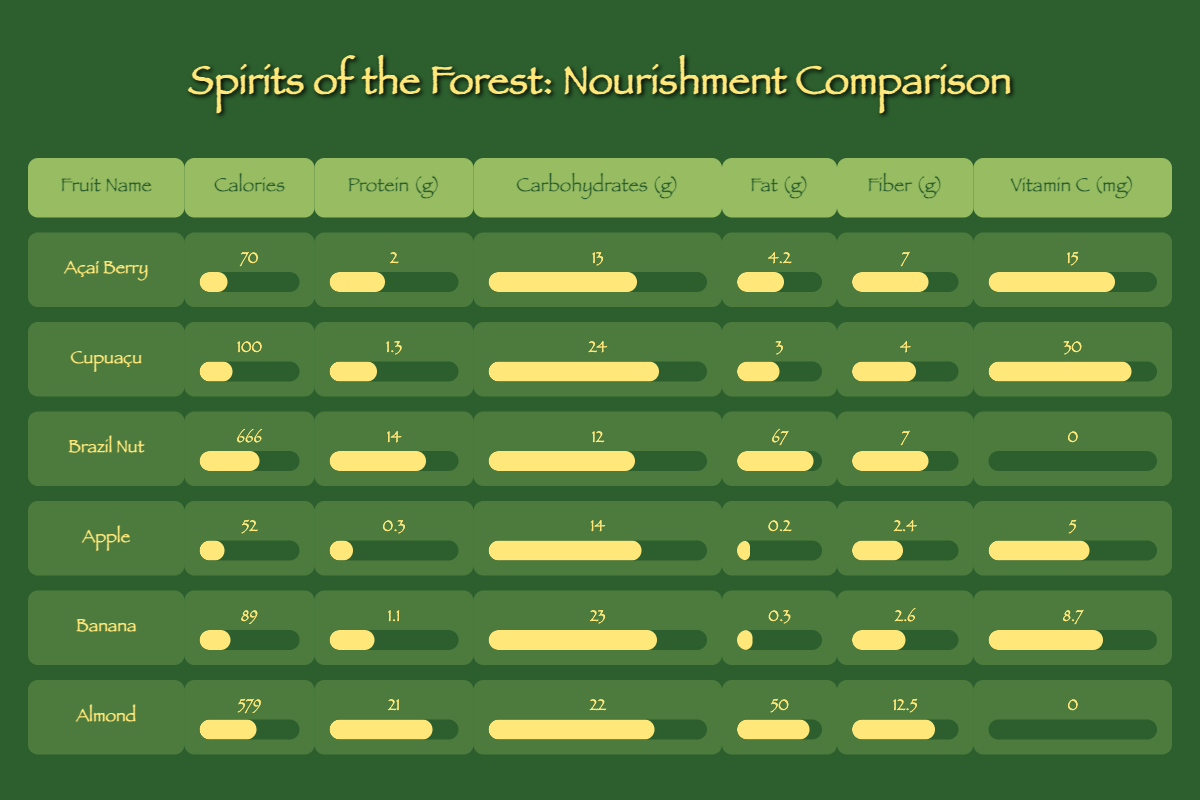What fruit has the highest calories among indigenous options? By looking at the indigenous fruits listed, the Brazil Nut has 666 calories, which is higher than Açaí Berry (70 calories) and Cupuaçu (100 calories).
Answer: Brazil Nut What is the vitamin C content of Cupuaçu? The vitamin C content of Cupuaçu is listed as 30 mg in the table.
Answer: 30 mg Which fruit has the highest fat content among cultivated fruits? The table shows that Almond has the highest fat content at 50 grams, compared to Apple (0.2 grams) and Banana (0.3 grams).
Answer: Almond Calculate the average protein content of indigenous fruits. The protein values for indigenous fruits are 2, 1.3, and 14 grams. The sum is 2 + 1.3 + 14 = 17. Dividing by 3 gives an average of 17/3 = 5.67 grams.
Answer: 5.67 grams Is it true that all cultivated fruits have higher calories than indigenous fruits? No, it's not true. The Brazil Nut has 666 calories, which is more than any cultivated fruit (Apple with 52 calories, Banana with 89 calories, Almond with 579 calories).
Answer: No What is the total carbohydrate content among indigenous fruits? The carbohydrate values for indigenous fruits are 13 (Açaí Berry) + 24 (Cupuaçu) + 12 (Brazil Nut) = 49 grams.
Answer: 49 grams Which fruit has the least fiber content among cultivated fruits? Checking the cultivated options, Apple has the least fiber content listed at 2.4 grams, whereas Banana has 2.6 grams and Almond has 12.5 grams.
Answer: Apple Which indigenous fruit has the lowest protein among these options? The Açaí Berry contains 2 grams of protein, which is lower than Cupuaçu (1.3 grams) and Brazil Nut (14 grams). Therefore, Açaí Berry has the lowest protein content among the indigenous fruits.
Answer: Cupuaçu Does the Brazil Nut contain any Vitamin C? No, the Brazil Nut has 0 mg of vitamin C as per the data provided in the table.
Answer: No 